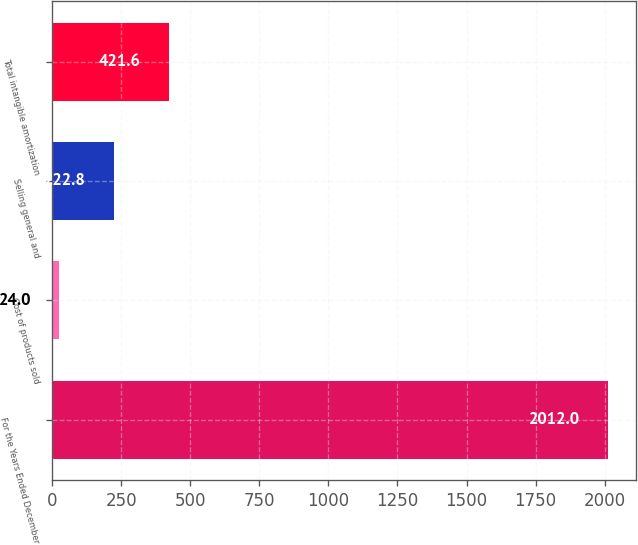Convert chart. <chart><loc_0><loc_0><loc_500><loc_500><bar_chart><fcel>For the Years Ended December<fcel>Cost of products sold<fcel>Selling general and<fcel>Total intangible amortization<nl><fcel>2012<fcel>24<fcel>222.8<fcel>421.6<nl></chart> 